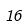Convert formula to latex. <formula><loc_0><loc_0><loc_500><loc_500>1 6</formula> 